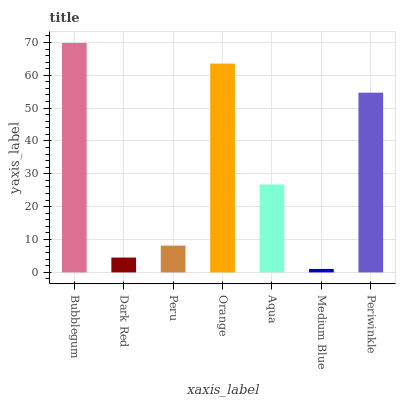Is Medium Blue the minimum?
Answer yes or no. Yes. Is Bubblegum the maximum?
Answer yes or no. Yes. Is Dark Red the minimum?
Answer yes or no. No. Is Dark Red the maximum?
Answer yes or no. No. Is Bubblegum greater than Dark Red?
Answer yes or no. Yes. Is Dark Red less than Bubblegum?
Answer yes or no. Yes. Is Dark Red greater than Bubblegum?
Answer yes or no. No. Is Bubblegum less than Dark Red?
Answer yes or no. No. Is Aqua the high median?
Answer yes or no. Yes. Is Aqua the low median?
Answer yes or no. Yes. Is Dark Red the high median?
Answer yes or no. No. Is Medium Blue the low median?
Answer yes or no. No. 